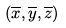Convert formula to latex. <formula><loc_0><loc_0><loc_500><loc_500>( \overline { x } , \overline { y } , \overline { z } )</formula> 